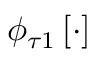Convert formula to latex. <formula><loc_0><loc_0><loc_500><loc_500>\phi _ { \tau 1 } \left [ \cdot \right ]</formula> 